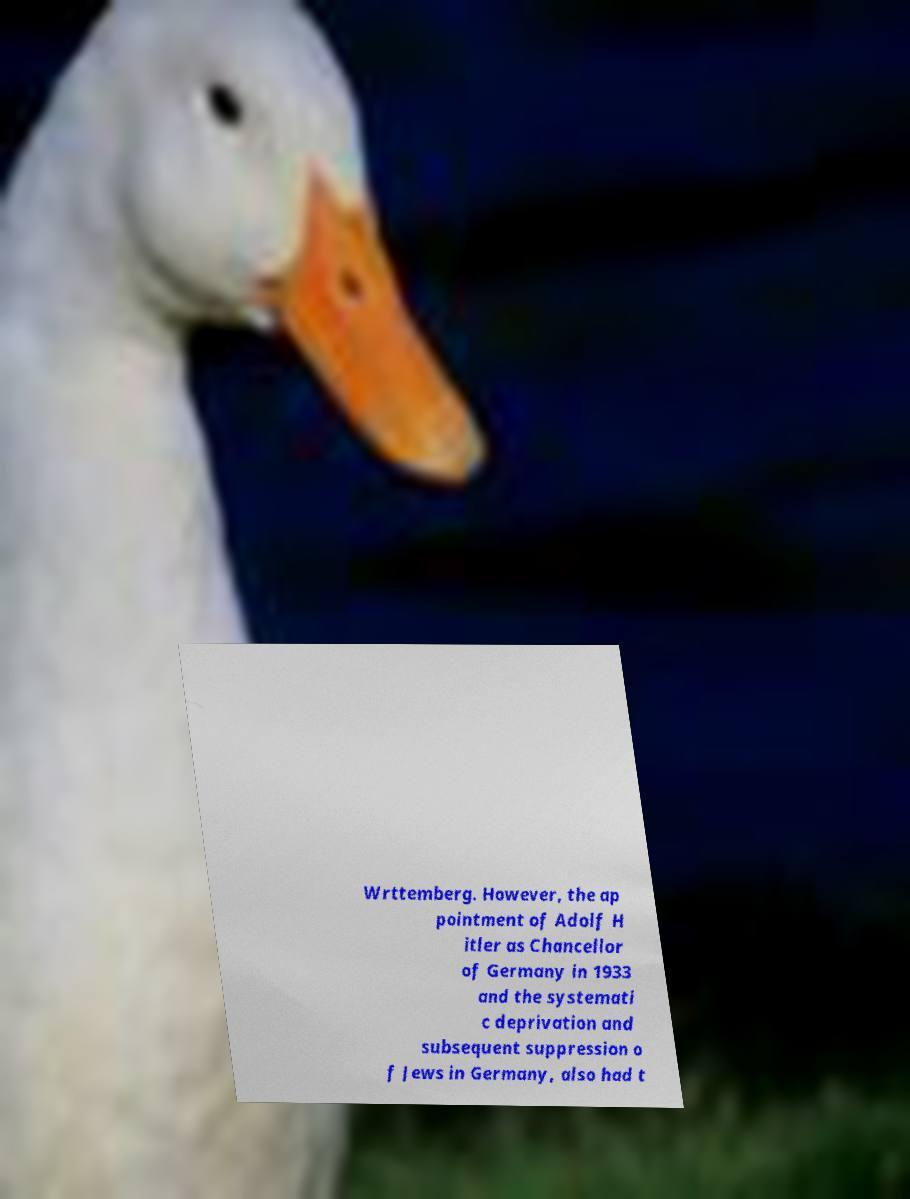For documentation purposes, I need the text within this image transcribed. Could you provide that? Wrttemberg. However, the ap pointment of Adolf H itler as Chancellor of Germany in 1933 and the systemati c deprivation and subsequent suppression o f Jews in Germany, also had t 